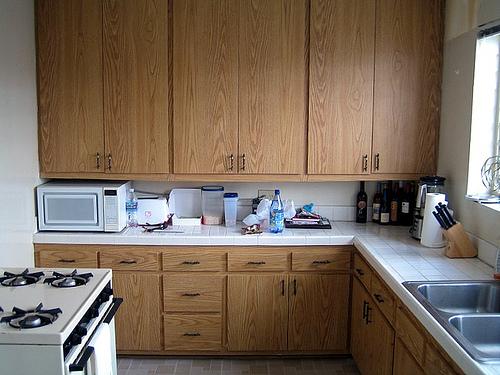Is there a washer in the kitchen?
Answer briefly. No. Is the kitchen modern?
Write a very short answer. Yes. What color are the cabinets?
Keep it brief. Brown. Are the curtains closed?
Quick response, please. No. Is the stove gas or electric?
Concise answer only. Gas. How many cabinets doors are on top?
Concise answer only. 6. Is this a tidy kitchen?
Concise answer only. Yes. 